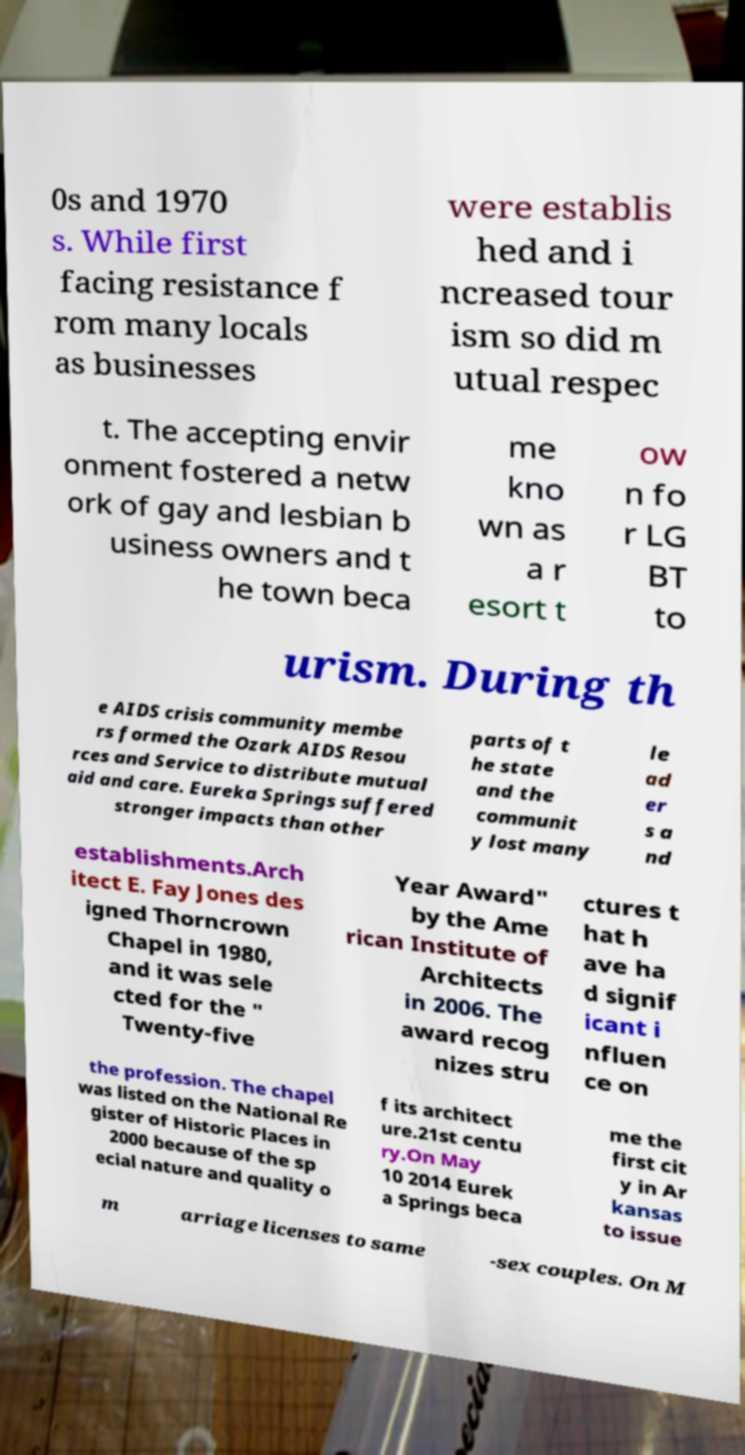Can you accurately transcribe the text from the provided image for me? 0s and 1970 s. While first facing resistance f rom many locals as businesses were establis hed and i ncreased tour ism so did m utual respec t. The accepting envir onment fostered a netw ork of gay and lesbian b usiness owners and t he town beca me kno wn as a r esort t ow n fo r LG BT to urism. During th e AIDS crisis community membe rs formed the Ozark AIDS Resou rces and Service to distribute mutual aid and care. Eureka Springs suffered stronger impacts than other parts of t he state and the communit y lost many le ad er s a nd establishments.Arch itect E. Fay Jones des igned Thorncrown Chapel in 1980, and it was sele cted for the " Twenty-five Year Award" by the Ame rican Institute of Architects in 2006. The award recog nizes stru ctures t hat h ave ha d signif icant i nfluen ce on the profession. The chapel was listed on the National Re gister of Historic Places in 2000 because of the sp ecial nature and quality o f its architect ure.21st centu ry.On May 10 2014 Eurek a Springs beca me the first cit y in Ar kansas to issue m arriage licenses to same -sex couples. On M 